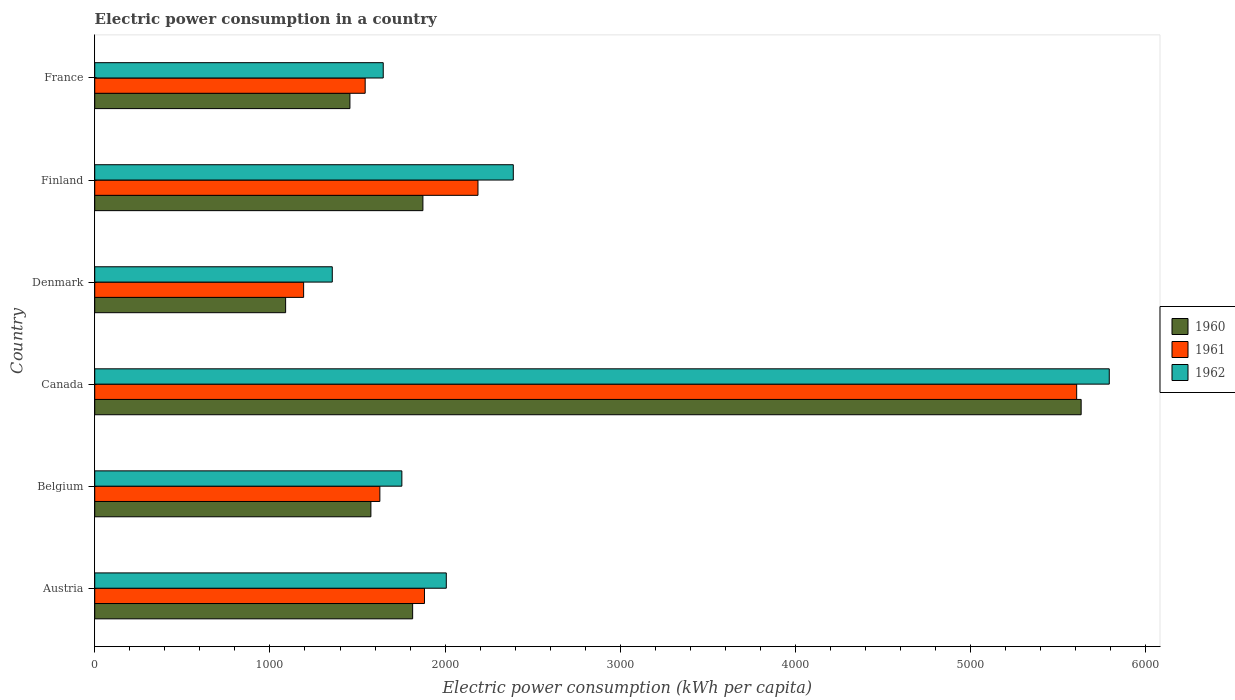How many groups of bars are there?
Provide a succinct answer. 6. Are the number of bars on each tick of the Y-axis equal?
Your response must be concise. Yes. In how many cases, is the number of bars for a given country not equal to the number of legend labels?
Your response must be concise. 0. What is the electric power consumption in in 1960 in Canada?
Your answer should be very brief. 5630.63. Across all countries, what is the maximum electric power consumption in in 1961?
Make the answer very short. 5605.11. Across all countries, what is the minimum electric power consumption in in 1962?
Your response must be concise. 1355.93. In which country was the electric power consumption in in 1961 maximum?
Ensure brevity in your answer.  Canada. What is the total electric power consumption in in 1961 in the graph?
Provide a succinct answer. 1.40e+04. What is the difference between the electric power consumption in in 1960 in Finland and that in France?
Offer a very short reply. 416.6. What is the difference between the electric power consumption in in 1960 in Denmark and the electric power consumption in in 1961 in Austria?
Provide a succinct answer. -792.61. What is the average electric power consumption in in 1960 per country?
Your response must be concise. 2240.21. What is the difference between the electric power consumption in in 1962 and electric power consumption in in 1961 in Finland?
Your answer should be very brief. 201.59. In how many countries, is the electric power consumption in in 1960 greater than 400 kWh per capita?
Provide a succinct answer. 6. What is the ratio of the electric power consumption in in 1961 in Belgium to that in France?
Ensure brevity in your answer.  1.05. Is the electric power consumption in in 1962 in Denmark less than that in Finland?
Offer a terse response. Yes. Is the difference between the electric power consumption in in 1962 in Austria and Denmark greater than the difference between the electric power consumption in in 1961 in Austria and Denmark?
Provide a succinct answer. No. What is the difference between the highest and the second highest electric power consumption in in 1960?
Ensure brevity in your answer.  3757.34. What is the difference between the highest and the lowest electric power consumption in in 1960?
Your response must be concise. 4541.02. In how many countries, is the electric power consumption in in 1962 greater than the average electric power consumption in in 1962 taken over all countries?
Offer a terse response. 1. Is the sum of the electric power consumption in in 1960 in Austria and Belgium greater than the maximum electric power consumption in in 1961 across all countries?
Give a very brief answer. No. How many countries are there in the graph?
Offer a terse response. 6. What is the difference between two consecutive major ticks on the X-axis?
Make the answer very short. 1000. Does the graph contain grids?
Your answer should be very brief. No. How are the legend labels stacked?
Make the answer very short. Vertical. What is the title of the graph?
Make the answer very short. Electric power consumption in a country. What is the label or title of the X-axis?
Your answer should be very brief. Electric power consumption (kWh per capita). What is the Electric power consumption (kWh per capita) in 1960 in Austria?
Offer a very short reply. 1814.68. What is the Electric power consumption (kWh per capita) in 1961 in Austria?
Offer a terse response. 1882.22. What is the Electric power consumption (kWh per capita) of 1962 in Austria?
Offer a very short reply. 2006.77. What is the Electric power consumption (kWh per capita) in 1960 in Belgium?
Keep it short and to the point. 1576.34. What is the Electric power consumption (kWh per capita) in 1961 in Belgium?
Your answer should be very brief. 1627.51. What is the Electric power consumption (kWh per capita) in 1962 in Belgium?
Your answer should be compact. 1753.14. What is the Electric power consumption (kWh per capita) of 1960 in Canada?
Ensure brevity in your answer.  5630.63. What is the Electric power consumption (kWh per capita) in 1961 in Canada?
Offer a terse response. 5605.11. What is the Electric power consumption (kWh per capita) in 1962 in Canada?
Your answer should be very brief. 5791.12. What is the Electric power consumption (kWh per capita) of 1960 in Denmark?
Keep it short and to the point. 1089.61. What is the Electric power consumption (kWh per capita) in 1961 in Denmark?
Your answer should be very brief. 1192.41. What is the Electric power consumption (kWh per capita) of 1962 in Denmark?
Your answer should be compact. 1355.93. What is the Electric power consumption (kWh per capita) in 1960 in Finland?
Your answer should be compact. 1873.29. What is the Electric power consumption (kWh per capita) in 1961 in Finland?
Provide a short and direct response. 2187.62. What is the Electric power consumption (kWh per capita) of 1962 in Finland?
Keep it short and to the point. 2389.21. What is the Electric power consumption (kWh per capita) of 1960 in France?
Provide a succinct answer. 1456.69. What is the Electric power consumption (kWh per capita) of 1961 in France?
Offer a terse response. 1543.71. What is the Electric power consumption (kWh per capita) of 1962 in France?
Give a very brief answer. 1646.83. Across all countries, what is the maximum Electric power consumption (kWh per capita) of 1960?
Ensure brevity in your answer.  5630.63. Across all countries, what is the maximum Electric power consumption (kWh per capita) of 1961?
Keep it short and to the point. 5605.11. Across all countries, what is the maximum Electric power consumption (kWh per capita) of 1962?
Your answer should be very brief. 5791.12. Across all countries, what is the minimum Electric power consumption (kWh per capita) in 1960?
Provide a short and direct response. 1089.61. Across all countries, what is the minimum Electric power consumption (kWh per capita) of 1961?
Your response must be concise. 1192.41. Across all countries, what is the minimum Electric power consumption (kWh per capita) in 1962?
Your response must be concise. 1355.93. What is the total Electric power consumption (kWh per capita) of 1960 in the graph?
Make the answer very short. 1.34e+04. What is the total Electric power consumption (kWh per capita) of 1961 in the graph?
Ensure brevity in your answer.  1.40e+04. What is the total Electric power consumption (kWh per capita) in 1962 in the graph?
Keep it short and to the point. 1.49e+04. What is the difference between the Electric power consumption (kWh per capita) in 1960 in Austria and that in Belgium?
Make the answer very short. 238.34. What is the difference between the Electric power consumption (kWh per capita) in 1961 in Austria and that in Belgium?
Offer a terse response. 254.71. What is the difference between the Electric power consumption (kWh per capita) in 1962 in Austria and that in Belgium?
Offer a terse response. 253.63. What is the difference between the Electric power consumption (kWh per capita) in 1960 in Austria and that in Canada?
Your response must be concise. -3815.95. What is the difference between the Electric power consumption (kWh per capita) of 1961 in Austria and that in Canada?
Make the answer very short. -3722.89. What is the difference between the Electric power consumption (kWh per capita) of 1962 in Austria and that in Canada?
Keep it short and to the point. -3784.35. What is the difference between the Electric power consumption (kWh per capita) of 1960 in Austria and that in Denmark?
Give a very brief answer. 725.06. What is the difference between the Electric power consumption (kWh per capita) of 1961 in Austria and that in Denmark?
Make the answer very short. 689.82. What is the difference between the Electric power consumption (kWh per capita) in 1962 in Austria and that in Denmark?
Provide a short and direct response. 650.84. What is the difference between the Electric power consumption (kWh per capita) in 1960 in Austria and that in Finland?
Your answer should be very brief. -58.62. What is the difference between the Electric power consumption (kWh per capita) in 1961 in Austria and that in Finland?
Your answer should be very brief. -305.4. What is the difference between the Electric power consumption (kWh per capita) in 1962 in Austria and that in Finland?
Ensure brevity in your answer.  -382.44. What is the difference between the Electric power consumption (kWh per capita) in 1960 in Austria and that in France?
Keep it short and to the point. 357.98. What is the difference between the Electric power consumption (kWh per capita) of 1961 in Austria and that in France?
Ensure brevity in your answer.  338.51. What is the difference between the Electric power consumption (kWh per capita) of 1962 in Austria and that in France?
Ensure brevity in your answer.  359.94. What is the difference between the Electric power consumption (kWh per capita) in 1960 in Belgium and that in Canada?
Provide a short and direct response. -4054.29. What is the difference between the Electric power consumption (kWh per capita) of 1961 in Belgium and that in Canada?
Ensure brevity in your answer.  -3977.6. What is the difference between the Electric power consumption (kWh per capita) of 1962 in Belgium and that in Canada?
Your response must be concise. -4037.98. What is the difference between the Electric power consumption (kWh per capita) of 1960 in Belgium and that in Denmark?
Your response must be concise. 486.72. What is the difference between the Electric power consumption (kWh per capita) of 1961 in Belgium and that in Denmark?
Your answer should be very brief. 435.11. What is the difference between the Electric power consumption (kWh per capita) of 1962 in Belgium and that in Denmark?
Offer a terse response. 397.21. What is the difference between the Electric power consumption (kWh per capita) in 1960 in Belgium and that in Finland?
Your answer should be very brief. -296.95. What is the difference between the Electric power consumption (kWh per capita) in 1961 in Belgium and that in Finland?
Your response must be concise. -560.11. What is the difference between the Electric power consumption (kWh per capita) of 1962 in Belgium and that in Finland?
Make the answer very short. -636.07. What is the difference between the Electric power consumption (kWh per capita) in 1960 in Belgium and that in France?
Offer a very short reply. 119.65. What is the difference between the Electric power consumption (kWh per capita) of 1961 in Belgium and that in France?
Your response must be concise. 83.8. What is the difference between the Electric power consumption (kWh per capita) of 1962 in Belgium and that in France?
Offer a terse response. 106.31. What is the difference between the Electric power consumption (kWh per capita) in 1960 in Canada and that in Denmark?
Provide a short and direct response. 4541.02. What is the difference between the Electric power consumption (kWh per capita) of 1961 in Canada and that in Denmark?
Provide a short and direct response. 4412.71. What is the difference between the Electric power consumption (kWh per capita) of 1962 in Canada and that in Denmark?
Make the answer very short. 4435.19. What is the difference between the Electric power consumption (kWh per capita) in 1960 in Canada and that in Finland?
Keep it short and to the point. 3757.34. What is the difference between the Electric power consumption (kWh per capita) of 1961 in Canada and that in Finland?
Keep it short and to the point. 3417.49. What is the difference between the Electric power consumption (kWh per capita) in 1962 in Canada and that in Finland?
Provide a succinct answer. 3401.92. What is the difference between the Electric power consumption (kWh per capita) in 1960 in Canada and that in France?
Provide a succinct answer. 4173.94. What is the difference between the Electric power consumption (kWh per capita) in 1961 in Canada and that in France?
Your answer should be compact. 4061.4. What is the difference between the Electric power consumption (kWh per capita) of 1962 in Canada and that in France?
Keep it short and to the point. 4144.29. What is the difference between the Electric power consumption (kWh per capita) of 1960 in Denmark and that in Finland?
Offer a terse response. -783.68. What is the difference between the Electric power consumption (kWh per capita) in 1961 in Denmark and that in Finland?
Your answer should be compact. -995.22. What is the difference between the Electric power consumption (kWh per capita) of 1962 in Denmark and that in Finland?
Give a very brief answer. -1033.28. What is the difference between the Electric power consumption (kWh per capita) in 1960 in Denmark and that in France?
Your answer should be very brief. -367.08. What is the difference between the Electric power consumption (kWh per capita) of 1961 in Denmark and that in France?
Provide a succinct answer. -351.31. What is the difference between the Electric power consumption (kWh per capita) of 1962 in Denmark and that in France?
Your response must be concise. -290.9. What is the difference between the Electric power consumption (kWh per capita) of 1960 in Finland and that in France?
Make the answer very short. 416.6. What is the difference between the Electric power consumption (kWh per capita) in 1961 in Finland and that in France?
Your answer should be very brief. 643.91. What is the difference between the Electric power consumption (kWh per capita) of 1962 in Finland and that in France?
Provide a succinct answer. 742.38. What is the difference between the Electric power consumption (kWh per capita) of 1960 in Austria and the Electric power consumption (kWh per capita) of 1961 in Belgium?
Your answer should be compact. 187.16. What is the difference between the Electric power consumption (kWh per capita) of 1960 in Austria and the Electric power consumption (kWh per capita) of 1962 in Belgium?
Your answer should be compact. 61.53. What is the difference between the Electric power consumption (kWh per capita) of 1961 in Austria and the Electric power consumption (kWh per capita) of 1962 in Belgium?
Offer a terse response. 129.08. What is the difference between the Electric power consumption (kWh per capita) of 1960 in Austria and the Electric power consumption (kWh per capita) of 1961 in Canada?
Ensure brevity in your answer.  -3790.44. What is the difference between the Electric power consumption (kWh per capita) in 1960 in Austria and the Electric power consumption (kWh per capita) in 1962 in Canada?
Offer a very short reply. -3976.45. What is the difference between the Electric power consumption (kWh per capita) of 1961 in Austria and the Electric power consumption (kWh per capita) of 1962 in Canada?
Provide a succinct answer. -3908.9. What is the difference between the Electric power consumption (kWh per capita) of 1960 in Austria and the Electric power consumption (kWh per capita) of 1961 in Denmark?
Your response must be concise. 622.27. What is the difference between the Electric power consumption (kWh per capita) of 1960 in Austria and the Electric power consumption (kWh per capita) of 1962 in Denmark?
Offer a terse response. 458.74. What is the difference between the Electric power consumption (kWh per capita) in 1961 in Austria and the Electric power consumption (kWh per capita) in 1962 in Denmark?
Give a very brief answer. 526.29. What is the difference between the Electric power consumption (kWh per capita) in 1960 in Austria and the Electric power consumption (kWh per capita) in 1961 in Finland?
Your answer should be compact. -372.95. What is the difference between the Electric power consumption (kWh per capita) in 1960 in Austria and the Electric power consumption (kWh per capita) in 1962 in Finland?
Offer a very short reply. -574.53. What is the difference between the Electric power consumption (kWh per capita) of 1961 in Austria and the Electric power consumption (kWh per capita) of 1962 in Finland?
Provide a succinct answer. -506.99. What is the difference between the Electric power consumption (kWh per capita) in 1960 in Austria and the Electric power consumption (kWh per capita) in 1961 in France?
Give a very brief answer. 270.96. What is the difference between the Electric power consumption (kWh per capita) of 1960 in Austria and the Electric power consumption (kWh per capita) of 1962 in France?
Your answer should be very brief. 167.84. What is the difference between the Electric power consumption (kWh per capita) of 1961 in Austria and the Electric power consumption (kWh per capita) of 1962 in France?
Offer a terse response. 235.39. What is the difference between the Electric power consumption (kWh per capita) of 1960 in Belgium and the Electric power consumption (kWh per capita) of 1961 in Canada?
Ensure brevity in your answer.  -4028.77. What is the difference between the Electric power consumption (kWh per capita) of 1960 in Belgium and the Electric power consumption (kWh per capita) of 1962 in Canada?
Make the answer very short. -4214.79. What is the difference between the Electric power consumption (kWh per capita) in 1961 in Belgium and the Electric power consumption (kWh per capita) in 1962 in Canada?
Give a very brief answer. -4163.61. What is the difference between the Electric power consumption (kWh per capita) in 1960 in Belgium and the Electric power consumption (kWh per capita) in 1961 in Denmark?
Give a very brief answer. 383.93. What is the difference between the Electric power consumption (kWh per capita) in 1960 in Belgium and the Electric power consumption (kWh per capita) in 1962 in Denmark?
Keep it short and to the point. 220.41. What is the difference between the Electric power consumption (kWh per capita) in 1961 in Belgium and the Electric power consumption (kWh per capita) in 1962 in Denmark?
Offer a very short reply. 271.58. What is the difference between the Electric power consumption (kWh per capita) of 1960 in Belgium and the Electric power consumption (kWh per capita) of 1961 in Finland?
Keep it short and to the point. -611.28. What is the difference between the Electric power consumption (kWh per capita) in 1960 in Belgium and the Electric power consumption (kWh per capita) in 1962 in Finland?
Ensure brevity in your answer.  -812.87. What is the difference between the Electric power consumption (kWh per capita) of 1961 in Belgium and the Electric power consumption (kWh per capita) of 1962 in Finland?
Your response must be concise. -761.7. What is the difference between the Electric power consumption (kWh per capita) of 1960 in Belgium and the Electric power consumption (kWh per capita) of 1961 in France?
Offer a very short reply. 32.63. What is the difference between the Electric power consumption (kWh per capita) in 1960 in Belgium and the Electric power consumption (kWh per capita) in 1962 in France?
Your response must be concise. -70.49. What is the difference between the Electric power consumption (kWh per capita) of 1961 in Belgium and the Electric power consumption (kWh per capita) of 1962 in France?
Make the answer very short. -19.32. What is the difference between the Electric power consumption (kWh per capita) of 1960 in Canada and the Electric power consumption (kWh per capita) of 1961 in Denmark?
Give a very brief answer. 4438.22. What is the difference between the Electric power consumption (kWh per capita) of 1960 in Canada and the Electric power consumption (kWh per capita) of 1962 in Denmark?
Ensure brevity in your answer.  4274.7. What is the difference between the Electric power consumption (kWh per capita) of 1961 in Canada and the Electric power consumption (kWh per capita) of 1962 in Denmark?
Your answer should be very brief. 4249.18. What is the difference between the Electric power consumption (kWh per capita) in 1960 in Canada and the Electric power consumption (kWh per capita) in 1961 in Finland?
Offer a terse response. 3443.01. What is the difference between the Electric power consumption (kWh per capita) of 1960 in Canada and the Electric power consumption (kWh per capita) of 1962 in Finland?
Offer a very short reply. 3241.42. What is the difference between the Electric power consumption (kWh per capita) of 1961 in Canada and the Electric power consumption (kWh per capita) of 1962 in Finland?
Make the answer very short. 3215.9. What is the difference between the Electric power consumption (kWh per capita) in 1960 in Canada and the Electric power consumption (kWh per capita) in 1961 in France?
Your response must be concise. 4086.92. What is the difference between the Electric power consumption (kWh per capita) of 1960 in Canada and the Electric power consumption (kWh per capita) of 1962 in France?
Provide a short and direct response. 3983.8. What is the difference between the Electric power consumption (kWh per capita) in 1961 in Canada and the Electric power consumption (kWh per capita) in 1962 in France?
Your answer should be compact. 3958.28. What is the difference between the Electric power consumption (kWh per capita) in 1960 in Denmark and the Electric power consumption (kWh per capita) in 1961 in Finland?
Offer a terse response. -1098.01. What is the difference between the Electric power consumption (kWh per capita) of 1960 in Denmark and the Electric power consumption (kWh per capita) of 1962 in Finland?
Ensure brevity in your answer.  -1299.6. What is the difference between the Electric power consumption (kWh per capita) of 1961 in Denmark and the Electric power consumption (kWh per capita) of 1962 in Finland?
Ensure brevity in your answer.  -1196.8. What is the difference between the Electric power consumption (kWh per capita) of 1960 in Denmark and the Electric power consumption (kWh per capita) of 1961 in France?
Your answer should be compact. -454.1. What is the difference between the Electric power consumption (kWh per capita) of 1960 in Denmark and the Electric power consumption (kWh per capita) of 1962 in France?
Provide a short and direct response. -557.22. What is the difference between the Electric power consumption (kWh per capita) of 1961 in Denmark and the Electric power consumption (kWh per capita) of 1962 in France?
Keep it short and to the point. -454.43. What is the difference between the Electric power consumption (kWh per capita) in 1960 in Finland and the Electric power consumption (kWh per capita) in 1961 in France?
Your answer should be very brief. 329.58. What is the difference between the Electric power consumption (kWh per capita) of 1960 in Finland and the Electric power consumption (kWh per capita) of 1962 in France?
Make the answer very short. 226.46. What is the difference between the Electric power consumption (kWh per capita) of 1961 in Finland and the Electric power consumption (kWh per capita) of 1962 in France?
Keep it short and to the point. 540.79. What is the average Electric power consumption (kWh per capita) of 1960 per country?
Your response must be concise. 2240.21. What is the average Electric power consumption (kWh per capita) in 1961 per country?
Provide a short and direct response. 2339.76. What is the average Electric power consumption (kWh per capita) in 1962 per country?
Your answer should be compact. 2490.5. What is the difference between the Electric power consumption (kWh per capita) in 1960 and Electric power consumption (kWh per capita) in 1961 in Austria?
Your response must be concise. -67.55. What is the difference between the Electric power consumption (kWh per capita) of 1960 and Electric power consumption (kWh per capita) of 1962 in Austria?
Provide a short and direct response. -192.09. What is the difference between the Electric power consumption (kWh per capita) in 1961 and Electric power consumption (kWh per capita) in 1962 in Austria?
Make the answer very short. -124.55. What is the difference between the Electric power consumption (kWh per capita) of 1960 and Electric power consumption (kWh per capita) of 1961 in Belgium?
Make the answer very short. -51.17. What is the difference between the Electric power consumption (kWh per capita) in 1960 and Electric power consumption (kWh per capita) in 1962 in Belgium?
Provide a succinct answer. -176.81. What is the difference between the Electric power consumption (kWh per capita) in 1961 and Electric power consumption (kWh per capita) in 1962 in Belgium?
Offer a terse response. -125.63. What is the difference between the Electric power consumption (kWh per capita) of 1960 and Electric power consumption (kWh per capita) of 1961 in Canada?
Your answer should be compact. 25.52. What is the difference between the Electric power consumption (kWh per capita) in 1960 and Electric power consumption (kWh per capita) in 1962 in Canada?
Your answer should be very brief. -160.5. What is the difference between the Electric power consumption (kWh per capita) in 1961 and Electric power consumption (kWh per capita) in 1962 in Canada?
Your answer should be very brief. -186.01. What is the difference between the Electric power consumption (kWh per capita) in 1960 and Electric power consumption (kWh per capita) in 1961 in Denmark?
Offer a very short reply. -102.79. What is the difference between the Electric power consumption (kWh per capita) of 1960 and Electric power consumption (kWh per capita) of 1962 in Denmark?
Keep it short and to the point. -266.32. What is the difference between the Electric power consumption (kWh per capita) in 1961 and Electric power consumption (kWh per capita) in 1962 in Denmark?
Ensure brevity in your answer.  -163.53. What is the difference between the Electric power consumption (kWh per capita) of 1960 and Electric power consumption (kWh per capita) of 1961 in Finland?
Provide a short and direct response. -314.33. What is the difference between the Electric power consumption (kWh per capita) of 1960 and Electric power consumption (kWh per capita) of 1962 in Finland?
Your answer should be compact. -515.92. What is the difference between the Electric power consumption (kWh per capita) of 1961 and Electric power consumption (kWh per capita) of 1962 in Finland?
Your answer should be very brief. -201.59. What is the difference between the Electric power consumption (kWh per capita) of 1960 and Electric power consumption (kWh per capita) of 1961 in France?
Provide a succinct answer. -87.02. What is the difference between the Electric power consumption (kWh per capita) in 1960 and Electric power consumption (kWh per capita) in 1962 in France?
Offer a very short reply. -190.14. What is the difference between the Electric power consumption (kWh per capita) in 1961 and Electric power consumption (kWh per capita) in 1962 in France?
Your answer should be compact. -103.12. What is the ratio of the Electric power consumption (kWh per capita) of 1960 in Austria to that in Belgium?
Keep it short and to the point. 1.15. What is the ratio of the Electric power consumption (kWh per capita) of 1961 in Austria to that in Belgium?
Keep it short and to the point. 1.16. What is the ratio of the Electric power consumption (kWh per capita) of 1962 in Austria to that in Belgium?
Keep it short and to the point. 1.14. What is the ratio of the Electric power consumption (kWh per capita) in 1960 in Austria to that in Canada?
Provide a short and direct response. 0.32. What is the ratio of the Electric power consumption (kWh per capita) of 1961 in Austria to that in Canada?
Keep it short and to the point. 0.34. What is the ratio of the Electric power consumption (kWh per capita) in 1962 in Austria to that in Canada?
Provide a short and direct response. 0.35. What is the ratio of the Electric power consumption (kWh per capita) in 1960 in Austria to that in Denmark?
Offer a terse response. 1.67. What is the ratio of the Electric power consumption (kWh per capita) of 1961 in Austria to that in Denmark?
Provide a short and direct response. 1.58. What is the ratio of the Electric power consumption (kWh per capita) in 1962 in Austria to that in Denmark?
Make the answer very short. 1.48. What is the ratio of the Electric power consumption (kWh per capita) of 1960 in Austria to that in Finland?
Give a very brief answer. 0.97. What is the ratio of the Electric power consumption (kWh per capita) in 1961 in Austria to that in Finland?
Make the answer very short. 0.86. What is the ratio of the Electric power consumption (kWh per capita) in 1962 in Austria to that in Finland?
Offer a very short reply. 0.84. What is the ratio of the Electric power consumption (kWh per capita) of 1960 in Austria to that in France?
Offer a terse response. 1.25. What is the ratio of the Electric power consumption (kWh per capita) of 1961 in Austria to that in France?
Give a very brief answer. 1.22. What is the ratio of the Electric power consumption (kWh per capita) of 1962 in Austria to that in France?
Your response must be concise. 1.22. What is the ratio of the Electric power consumption (kWh per capita) in 1960 in Belgium to that in Canada?
Your answer should be compact. 0.28. What is the ratio of the Electric power consumption (kWh per capita) in 1961 in Belgium to that in Canada?
Your answer should be compact. 0.29. What is the ratio of the Electric power consumption (kWh per capita) of 1962 in Belgium to that in Canada?
Offer a very short reply. 0.3. What is the ratio of the Electric power consumption (kWh per capita) in 1960 in Belgium to that in Denmark?
Give a very brief answer. 1.45. What is the ratio of the Electric power consumption (kWh per capita) in 1961 in Belgium to that in Denmark?
Your answer should be compact. 1.36. What is the ratio of the Electric power consumption (kWh per capita) in 1962 in Belgium to that in Denmark?
Offer a very short reply. 1.29. What is the ratio of the Electric power consumption (kWh per capita) in 1960 in Belgium to that in Finland?
Offer a terse response. 0.84. What is the ratio of the Electric power consumption (kWh per capita) of 1961 in Belgium to that in Finland?
Make the answer very short. 0.74. What is the ratio of the Electric power consumption (kWh per capita) of 1962 in Belgium to that in Finland?
Your answer should be very brief. 0.73. What is the ratio of the Electric power consumption (kWh per capita) of 1960 in Belgium to that in France?
Your response must be concise. 1.08. What is the ratio of the Electric power consumption (kWh per capita) of 1961 in Belgium to that in France?
Offer a terse response. 1.05. What is the ratio of the Electric power consumption (kWh per capita) of 1962 in Belgium to that in France?
Your response must be concise. 1.06. What is the ratio of the Electric power consumption (kWh per capita) in 1960 in Canada to that in Denmark?
Offer a very short reply. 5.17. What is the ratio of the Electric power consumption (kWh per capita) of 1961 in Canada to that in Denmark?
Your answer should be very brief. 4.7. What is the ratio of the Electric power consumption (kWh per capita) in 1962 in Canada to that in Denmark?
Offer a terse response. 4.27. What is the ratio of the Electric power consumption (kWh per capita) of 1960 in Canada to that in Finland?
Provide a succinct answer. 3.01. What is the ratio of the Electric power consumption (kWh per capita) of 1961 in Canada to that in Finland?
Your response must be concise. 2.56. What is the ratio of the Electric power consumption (kWh per capita) of 1962 in Canada to that in Finland?
Provide a short and direct response. 2.42. What is the ratio of the Electric power consumption (kWh per capita) of 1960 in Canada to that in France?
Provide a succinct answer. 3.87. What is the ratio of the Electric power consumption (kWh per capita) of 1961 in Canada to that in France?
Provide a succinct answer. 3.63. What is the ratio of the Electric power consumption (kWh per capita) in 1962 in Canada to that in France?
Offer a terse response. 3.52. What is the ratio of the Electric power consumption (kWh per capita) in 1960 in Denmark to that in Finland?
Give a very brief answer. 0.58. What is the ratio of the Electric power consumption (kWh per capita) in 1961 in Denmark to that in Finland?
Offer a very short reply. 0.55. What is the ratio of the Electric power consumption (kWh per capita) of 1962 in Denmark to that in Finland?
Your answer should be compact. 0.57. What is the ratio of the Electric power consumption (kWh per capita) in 1960 in Denmark to that in France?
Your response must be concise. 0.75. What is the ratio of the Electric power consumption (kWh per capita) in 1961 in Denmark to that in France?
Ensure brevity in your answer.  0.77. What is the ratio of the Electric power consumption (kWh per capita) in 1962 in Denmark to that in France?
Your answer should be compact. 0.82. What is the ratio of the Electric power consumption (kWh per capita) of 1960 in Finland to that in France?
Your answer should be very brief. 1.29. What is the ratio of the Electric power consumption (kWh per capita) in 1961 in Finland to that in France?
Make the answer very short. 1.42. What is the ratio of the Electric power consumption (kWh per capita) in 1962 in Finland to that in France?
Your response must be concise. 1.45. What is the difference between the highest and the second highest Electric power consumption (kWh per capita) in 1960?
Your answer should be compact. 3757.34. What is the difference between the highest and the second highest Electric power consumption (kWh per capita) of 1961?
Make the answer very short. 3417.49. What is the difference between the highest and the second highest Electric power consumption (kWh per capita) of 1962?
Ensure brevity in your answer.  3401.92. What is the difference between the highest and the lowest Electric power consumption (kWh per capita) of 1960?
Keep it short and to the point. 4541.02. What is the difference between the highest and the lowest Electric power consumption (kWh per capita) of 1961?
Your answer should be compact. 4412.71. What is the difference between the highest and the lowest Electric power consumption (kWh per capita) in 1962?
Your answer should be very brief. 4435.19. 